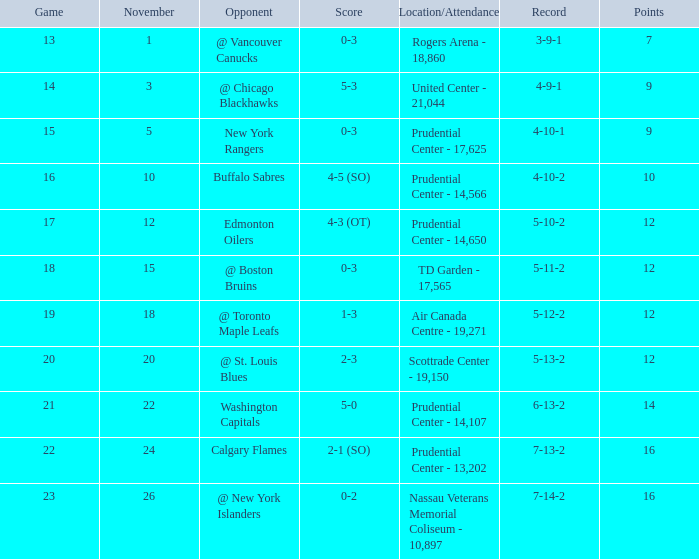Who was the opponent where the game is 14? @ Chicago Blackhawks. 